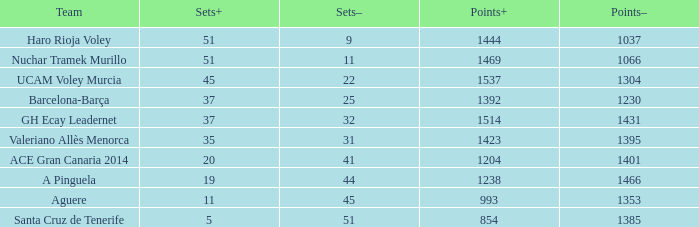When considering a points- value greater than 1385, a sets+ value less than 37, and a sets- value more than 41, what is the highest possible points+ number? 1238.0. 